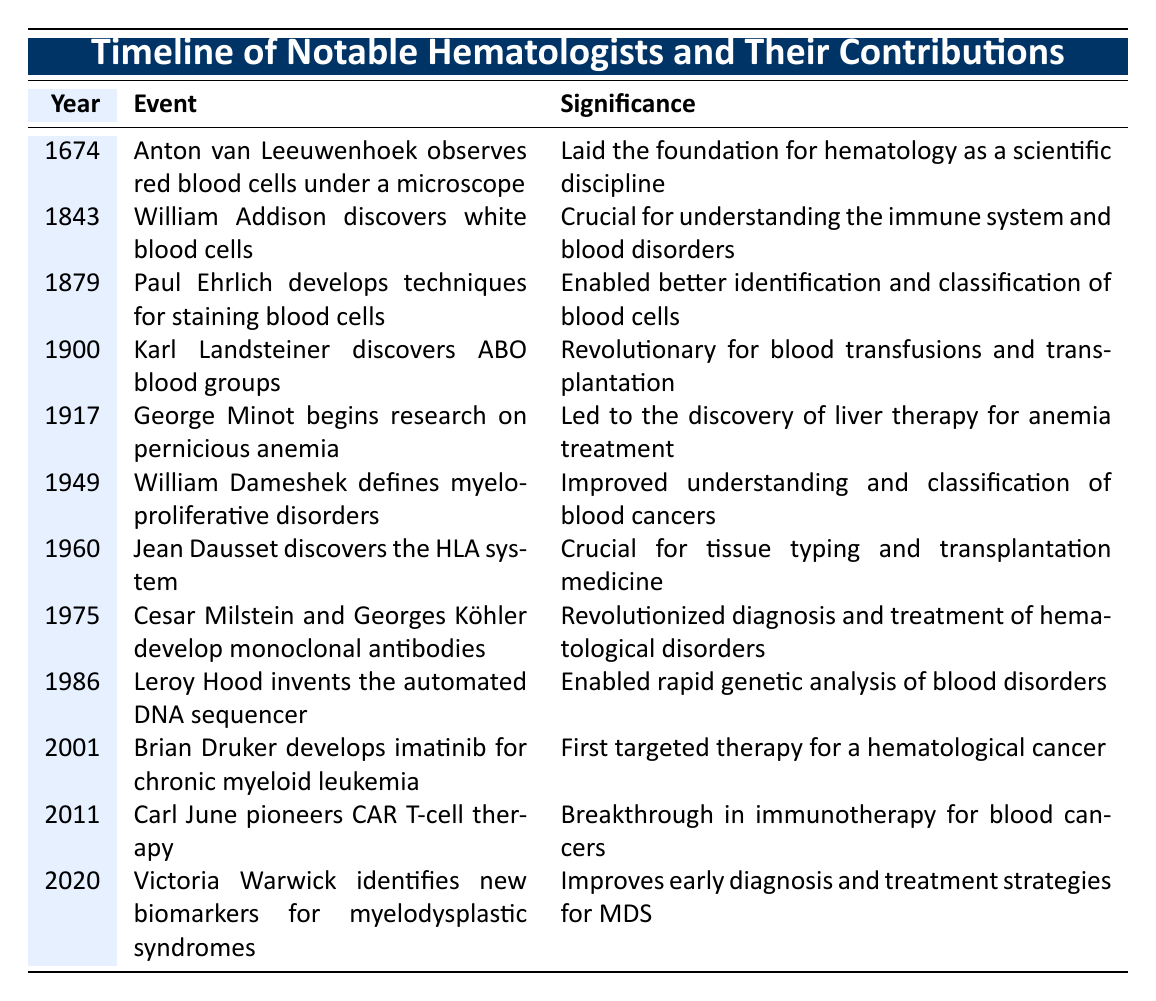What year did Anton van Leeuwenhoek observe red blood cells? The table lists Anton van Leeuwenhoek's observation in the year column, indicating he observed red blood cells in 1674.
Answer: 1674 Which event is associated with the discovery of the ABO blood groups? By looking at the event column, Karl Landsteiner is noted for discovering ABO blood groups in 1900.
Answer: Karl Landsteiner discovers ABO blood groups in 1900 Was César Milstein's contribution to hematology made before 1980? Checking the timeline, César Milstein's development of monoclonal antibodies occurred in 1975, which is indeed before 1980.
Answer: Yes Which two contributions occurred in the 1900s and relate to blood disorders? The events of discovering ABO blood groups in 1900 and defining myeloproliferative disorders in 1949 occurred in the 1900s and relate to blood disorders.
Answer: Karl Landsteiner and William Dameshek What is the significance of Brian Druker's development mentioned in the table? Referring to the significance column, it states that Brian Druker developed imatinib for chronic myeloid leukemia in 2001, which was the first targeted therapy for a hematological cancer.
Answer: First targeted therapy for a hematological cancer How many years passed between the discoveries of blood groups and the HLA system? The ABO blood groups were discovered in 1900, and the HLA system was discovered in 1960. The difference is 1960 - 1900 = 60 years.
Answer: 60 years Which contribution improved early diagnosis and treatment strategies, and who is credited for it? The table indicates that Victoria Warwick identified new biomarkers for myelodysplastic syndromes in 2020, which improved early diagnosis and treatment strategies for MDS.
Answer: Victoria Warwick Is it true that Paul Ehrlich's contribution was significant for the classification of blood cells? According to the significance noted in the table, Paul's techniques for staining blood cells did enable better identification and classification, supporting that this fact is true.
Answer: Yes Which hematologist contributed to tissue typing, and what was the year of the discovery? Jean Dausset discovered the HLA system in 1960, thereby contributing to tissue typing.
Answer: Jean Dausset in 1960 